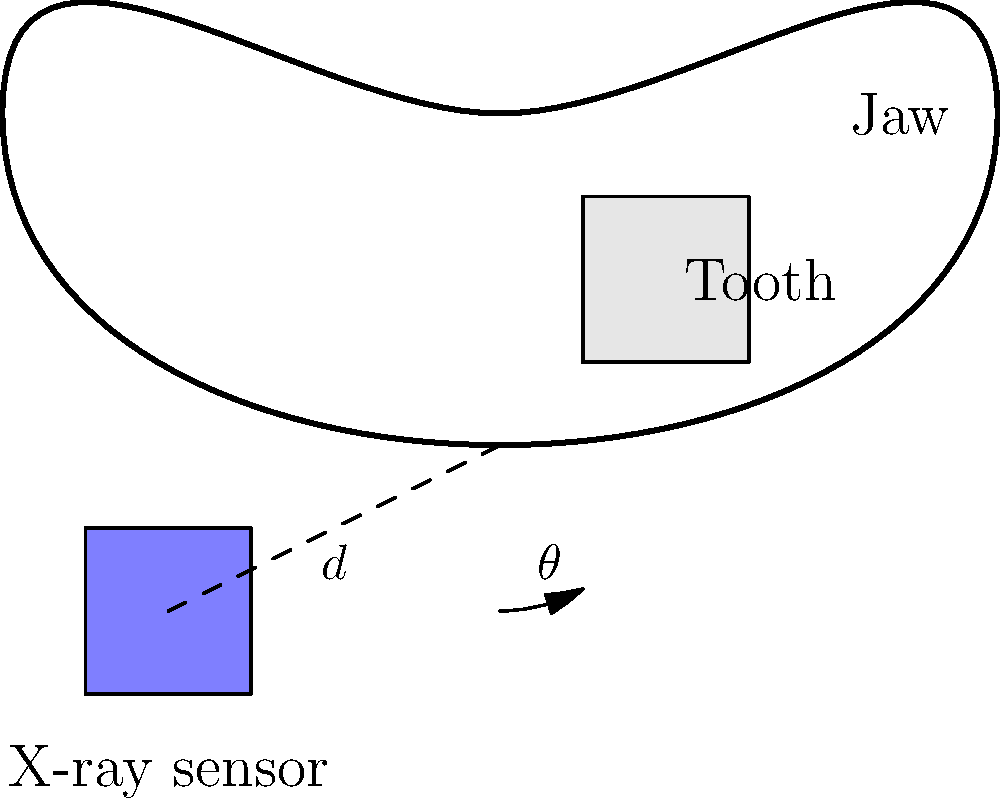An X-ray sensor needs to be positioned at an optimal angle $\theta$ from the vertical axis to capture a clear image of a tooth. If the distance $d$ between the sensor and the tooth is 5 cm, and the optimal angle $\theta$ is 30°, what is the vertical distance $h$ (in cm) between the sensor and the base of the tooth? To solve this problem, we'll use trigonometry, specifically the sine function. Here's a step-by-step explanation:

1) In a right-angled triangle formed by the vertical line from the tooth to the sensor, the line connecting the tooth and sensor, and the vertical distance we're looking for:

   - The hypotenuse is the distance $d$ (5 cm)
   - The angle between the hypotenuse and the vertical is $\theta$ (30°)
   - We need to find the opposite side, which is our vertical distance $h$

2) The sine of an angle in a right-angled triangle is the ratio of the opposite side to the hypotenuse:

   $\sin(\theta) = \frac{\text{opposite}}{\text{hypotenuse}} = \frac{h}{d}$

3) We can rearrange this to solve for $h$:

   $h = d \times \sin(\theta)$

4) Now we can substitute our known values:

   $h = 5 \times \sin(30°)$

5) $\sin(30°)$ is a standard angle and equals $\frac{1}{2}$, so:

   $h = 5 \times \frac{1}{2} = 2.5$

Therefore, the vertical distance $h$ between the sensor and the base of the tooth is 2.5 cm.
Answer: 2.5 cm 